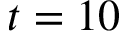<formula> <loc_0><loc_0><loc_500><loc_500>t = 1 0</formula> 